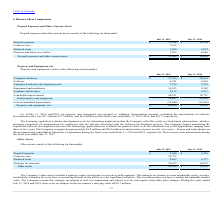According to Guidewire Software's financial document, What does the company's other assets include? a strategic equity investment in a privately-held company.. The document states: "The Company’s other assets includes a strategic equity investment in a privately-held company. The strategic investment is a non-marketable equity sec..." Also, What was the investment's carrying value in 2019? According to the financial document, $10.7 million. The relevant text states: "e no changes in the investment’s carrying value of $10.7 million...." Also, What was the Prepaid expenses in 2019 and 2018 respectively? The document shows two values: $2,640 and $2,476 (in thousands). From the document: "Prepaid expenses $ 2,640 $ 2,476 Prepaid expenses $ 2,640 $ 2,476..." Also, can you calculate: What was the average Contract costs for 2018 and 2019? To answer this question, I need to perform calculations using the financial data. The calculation is: (23,375 + 0) / 2, which equals 11687.5 (in thousands). This is based on the information: "Contract costs 23,375 — July 31, 2019 July 31, 2018..." The key data points involved are: 0, 23,375. Also, can you calculate: What was the change in the Deferred costs from 2018 to 2019? Based on the calculation: 8,867 - 9,377, the result is -510 (in thousands). This is based on the information: "Deferred costs 8,867 9,377 Deferred costs 8,867 9,377..." The key data points involved are: 8,867, 9,377. Additionally, In which year was Other assets less than 30,000 thousands? According to the financial document, 2018. The relevant text states: "July 31, 2019 July 31, 2018..." 